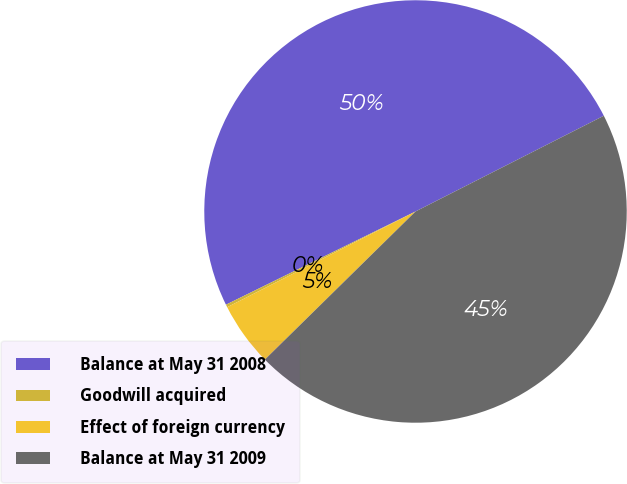<chart> <loc_0><loc_0><loc_500><loc_500><pie_chart><fcel>Balance at May 31 2008<fcel>Goodwill acquired<fcel>Effect of foreign currency<fcel>Balance at May 31 2009<nl><fcel>49.79%<fcel>0.21%<fcel>4.88%<fcel>45.12%<nl></chart> 